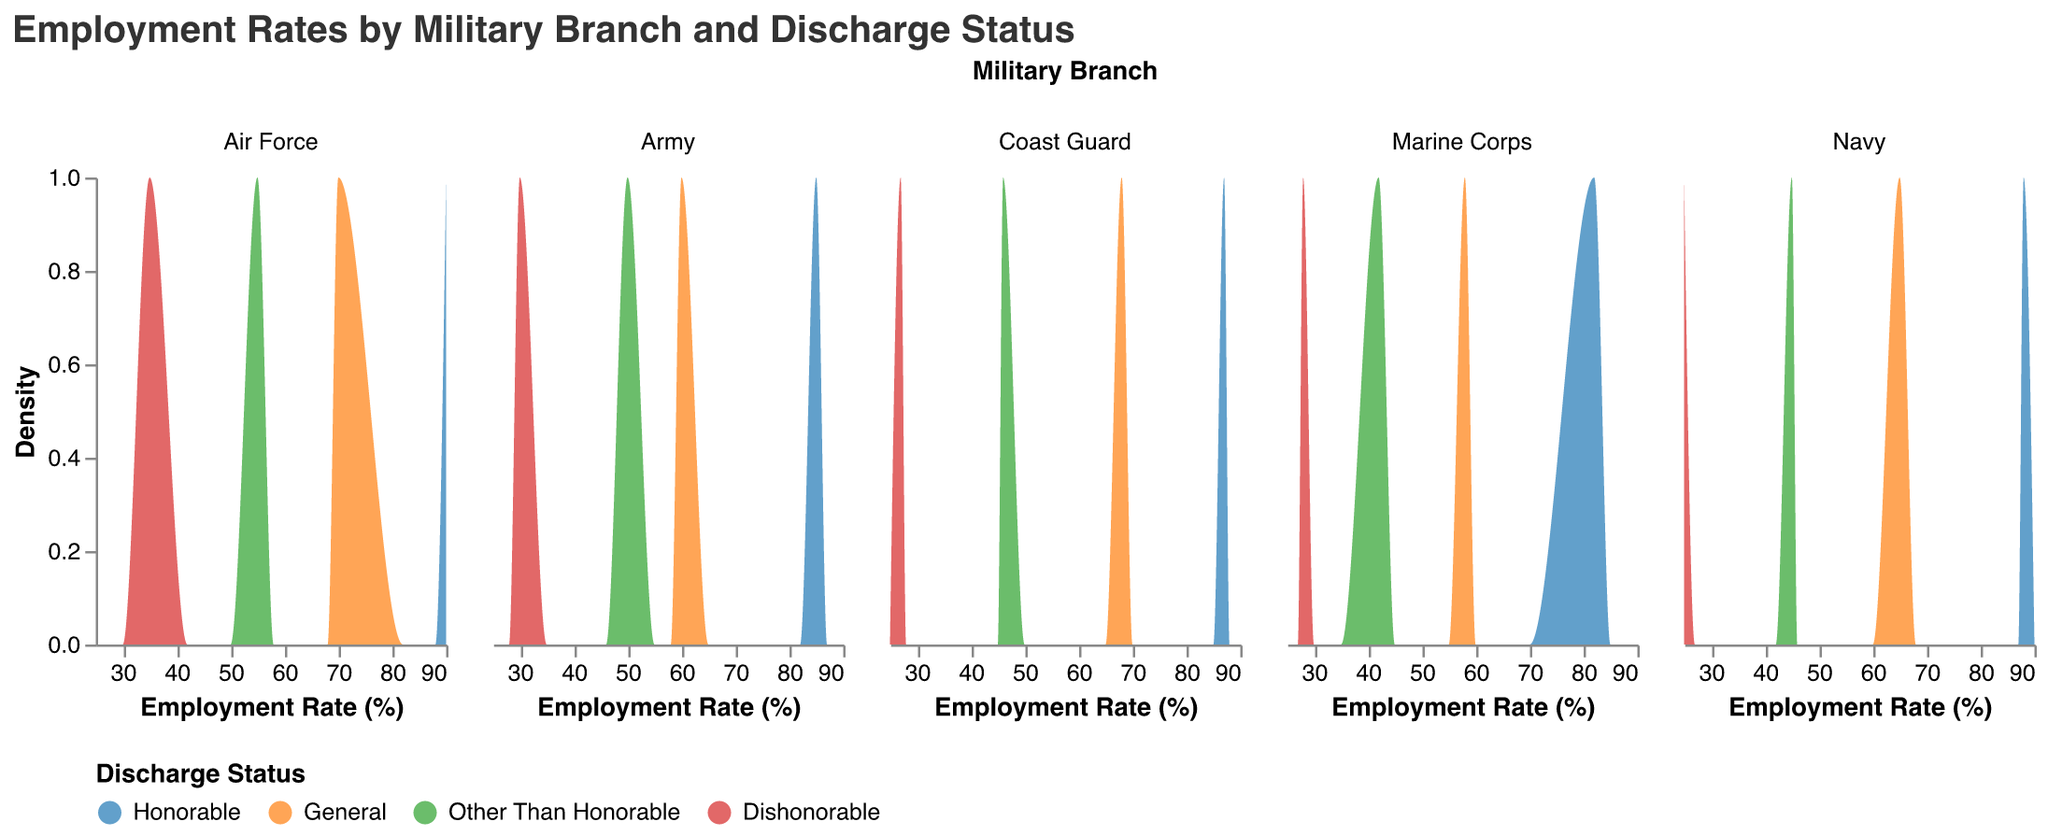What is the title of the figure? The title of the figure is located at the top and describes the overall content of the visualization. The title is "Employment Rates by Military Branch and Discharge Status".
Answer: Employment Rates by Military Branch and Discharge Status Which military branch has the highest employment rate for those with an Honorable discharge? To answer this, look at the x-axis of each subplot representing different branches and find the highest Employment Rate for Honorable discharge. The Air Force has the highest with a rate of 90.
Answer: Air Force How does the employment rate for General discharges compare between the Army and Navy? Compare the x-axis values for General discharges in the Army and Navy subplots. The Army has an employment rate of 60%, while the Navy has 65%.
Answer: The Navy has a higher employment rate What is the general trend in employment rates across all branches as discharge status changes from Honorable to Dishonorable? Examine the density of each discharge status. Employment rates generally decrease as discharge status changes from Honorable to Dishonorable in all branches.
Answer: Employment rates decrease Which discharge status has the lowest employment rate in each branch? Identify the discharge status with the lowest x-axis value in each subplot. In all branches, Dishonorable discharge has the lowest employment rate.
Answer: Dishonorable discharge How does the employment rate for Other Than Honorable discharges in the Marine Corps compare to the Coast Guard? Compare the employment rates for Other Than Honorable discharges between the Marine Corps and Coast Guard subplots. The Marine Corps has 42% and the Coast Guard has 46%.
Answer: The Coast Guard's rate is higher Which branch shows the most significant difference in employment rate between Honorable and Dishonorable discharges? Calculate the difference in employment rates for Honorable and Dishonorable discharges in each branch. The Army shows a difference of 55% (85 - 30).
Answer: Army What is the average employment rate for General discharges across all branches? Add the employment rates for General discharges in all branches and divide by the number of branches: (60+65+70+58+68)/5 = 64.2.
Answer: 64.2 Is there any branch where the employment rate for General discharges is higher than Other Than Honorable discharges by more than 20%? Compare the differences between General and Other Than Honorable discharges in each branch. The Air Force shows a difference of 15% (70 - 55), and no branch exceeds 20%.
Answer: No Which branch has the smallest decrease in employment rate when moving from Other Than Honorable to Dishonorable discharge? Calculate the employment rate differences between Other Than Honorable and Dishonorable discharges for each branch. The Air Force has the smallest decrease of 20% (55 - 35).
Answer: Air Force 